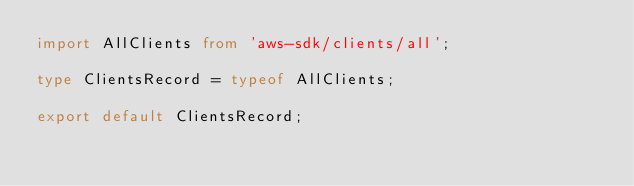Convert code to text. <code><loc_0><loc_0><loc_500><loc_500><_TypeScript_>import AllClients from 'aws-sdk/clients/all';

type ClientsRecord = typeof AllClients;

export default ClientsRecord;
</code> 